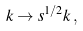Convert formula to latex. <formula><loc_0><loc_0><loc_500><loc_500>k \rightarrow s ^ { 1 / 2 } k \, ,</formula> 